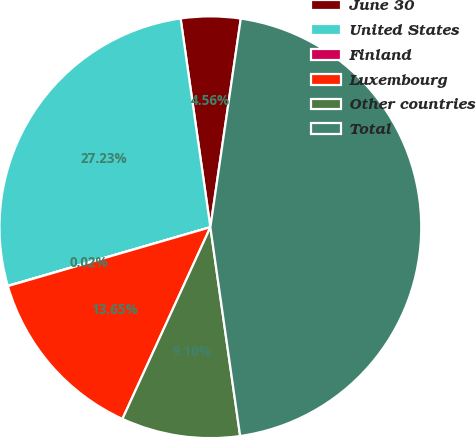Convert chart to OTSL. <chart><loc_0><loc_0><loc_500><loc_500><pie_chart><fcel>June 30<fcel>United States<fcel>Finland<fcel>Luxembourg<fcel>Other countries<fcel>Total<nl><fcel>4.56%<fcel>27.23%<fcel>0.02%<fcel>13.65%<fcel>9.1%<fcel>45.44%<nl></chart> 